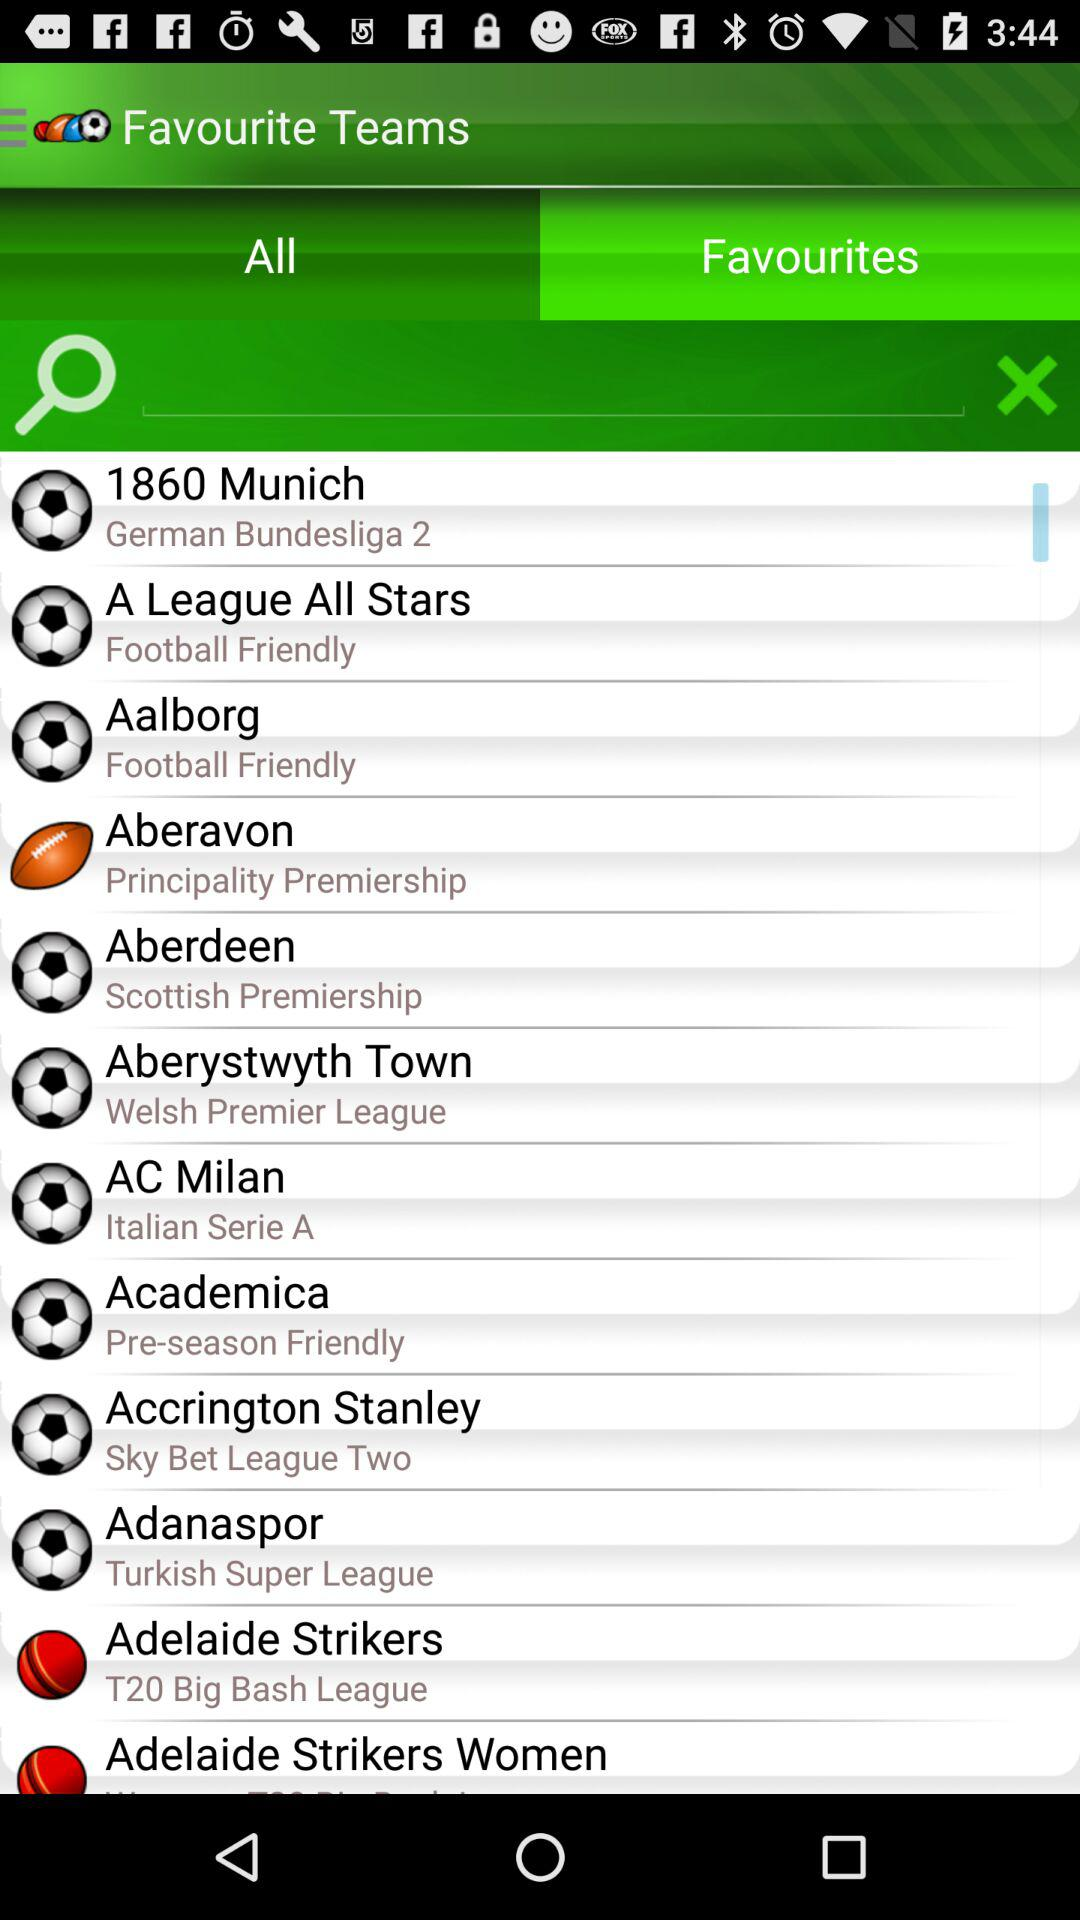What is the name of the league in which "Aberystwyth Town" will play? The name of the league is "Welsh Premier League". 